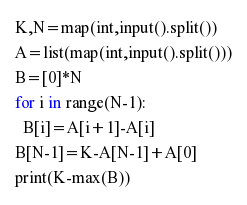Convert code to text. <code><loc_0><loc_0><loc_500><loc_500><_Python_>K,N=map(int,input().split())
A=list(map(int,input().split()))
B=[0]*N
for i in range(N-1):
  B[i]=A[i+1]-A[i]
B[N-1]=K-A[N-1]+A[0]
print(K-max(B))</code> 